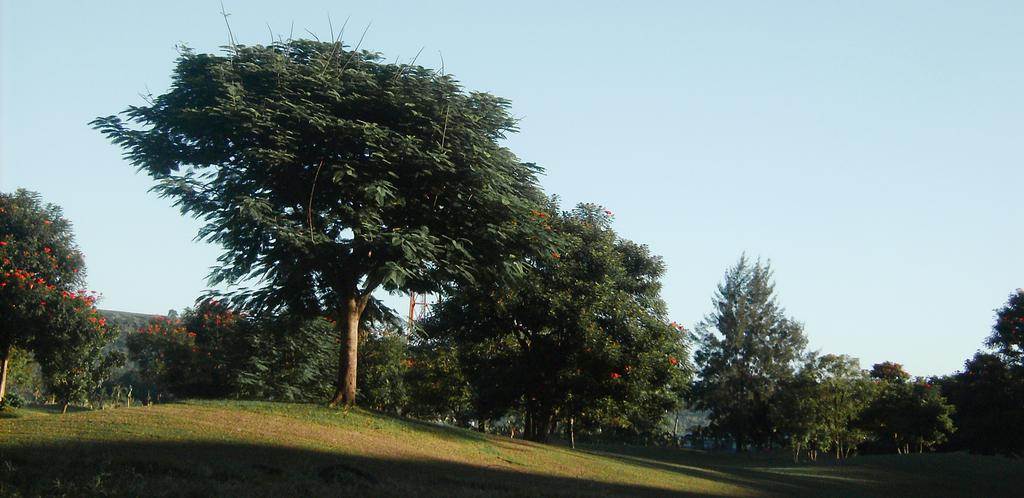What type of vegetation can be seen in the image? There are trees in the image. What part of the natural environment is visible in the image? The ground is visible in the image. What can be seen in the background of the image? The sky is visible in the background of the image. What type of fruit is hanging from the trees in the image? There is no fruit visible in the image; only trees are present. Is there a hose connected to the trees in the image? There is no hose present in the image. 